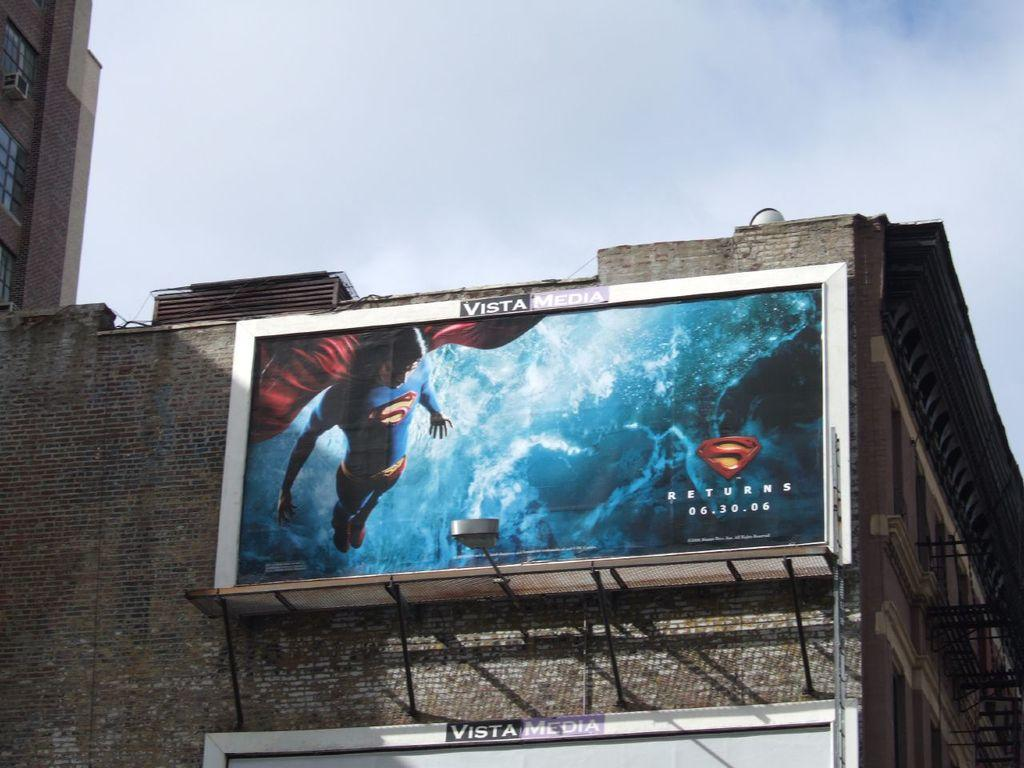<image>
Describe the image concisely. A big billboard sign advertising the movie Superman Returns, starting 06.30.06. 